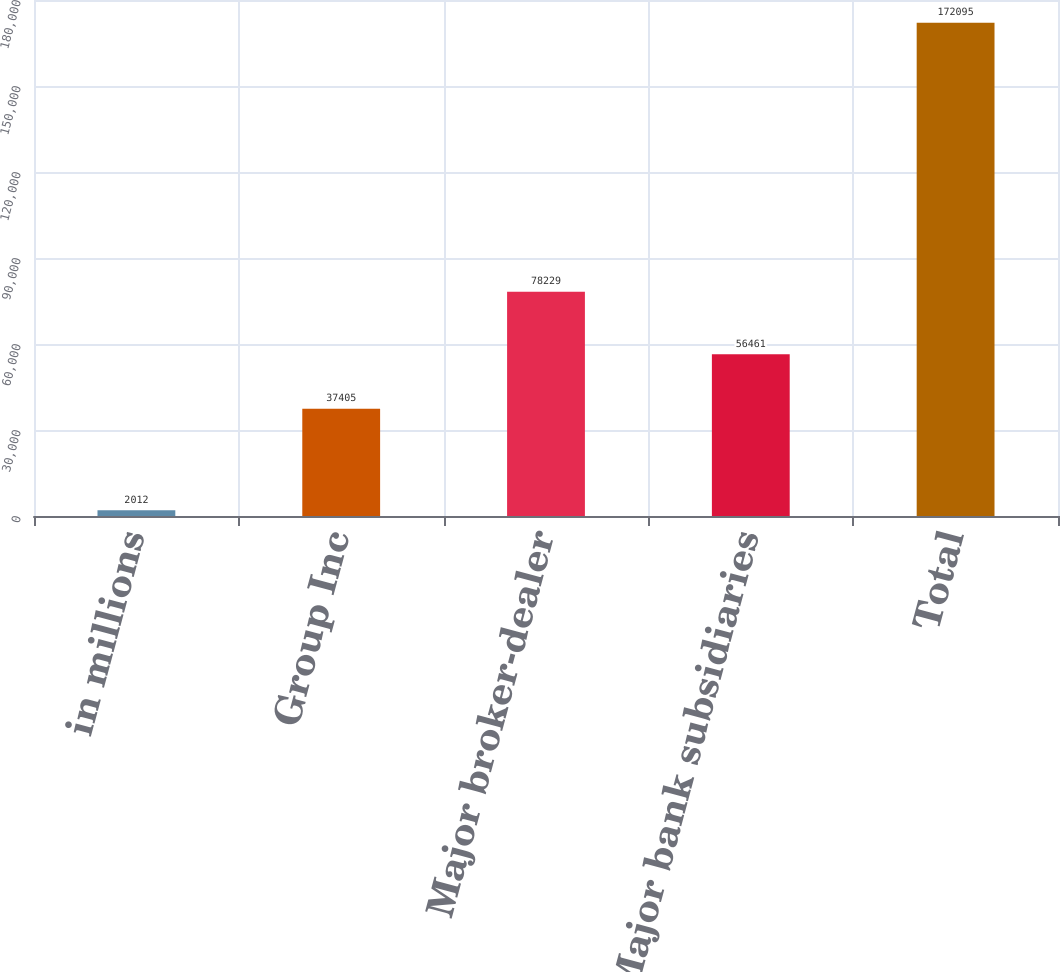<chart> <loc_0><loc_0><loc_500><loc_500><bar_chart><fcel>in millions<fcel>Group Inc<fcel>Major broker-dealer<fcel>Major bank subsidiaries<fcel>Total<nl><fcel>2012<fcel>37405<fcel>78229<fcel>56461<fcel>172095<nl></chart> 